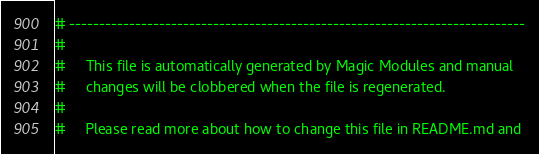Convert code to text. <code><loc_0><loc_0><loc_500><loc_500><_Ruby_># ----------------------------------------------------------------------------
#
#     This file is automatically generated by Magic Modules and manual
#     changes will be clobbered when the file is regenerated.
#
#     Please read more about how to change this file in README.md and</code> 